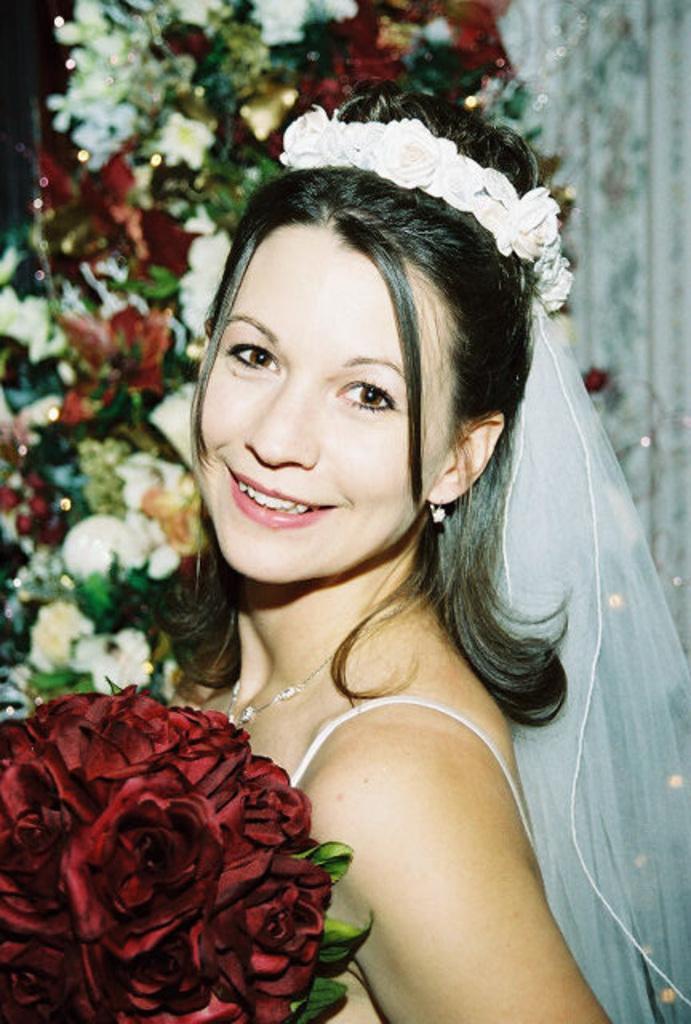How would you summarize this image in a sentence or two? In this image we can see a woman wearing dress, headwear is holding a flower bouquet and smiling. The background of the image is blurred, where we can see flowers. 